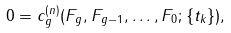<formula> <loc_0><loc_0><loc_500><loc_500>0 = c _ { g } ^ { ( n ) } ( F _ { g } , F _ { g - 1 } , \dots , F _ { 0 } ; \{ t _ { k } \} ) ,</formula> 